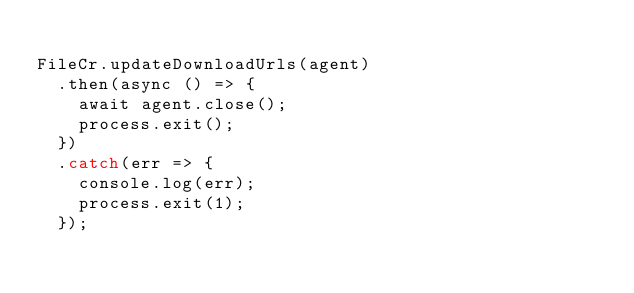Convert code to text. <code><loc_0><loc_0><loc_500><loc_500><_TypeScript_>
FileCr.updateDownloadUrls(agent)
  .then(async () => {
    await agent.close();
    process.exit();
  })
  .catch(err => {
    console.log(err);
    process.exit(1);
  });
</code> 